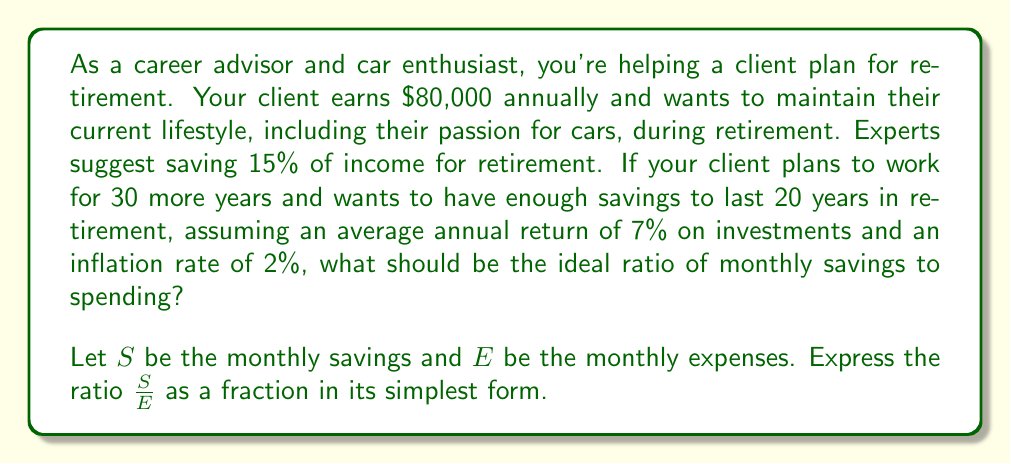Can you answer this question? To solve this problem, we'll follow these steps:

1) Calculate the monthly income:
   $\frac{\$80,000}{12} = \$6,666.67$ per month

2) Calculate the recommended monthly savings:
   $15\% \text{ of } \$6,666.67 = 0.15 \times \$6,666.67 = \$1,000$

3) Calculate the monthly expenses:
   $E = \$6,666.67 - \$1,000 = \$5,666.67$

4) Express the ratio of savings to expenses:
   $\frac{S}{E} = \frac{1000}{5666.67} = \frac{1000}{5666.67} \times \frac{3}{3} = \frac{3000}{17000}$

5) Simplify the fraction:
   $\frac{3000}{17000} = \frac{3}{17}$

This ratio suggests that for every $17 spent, $3 should be saved for retirement.

To verify if this savings rate is sufficient:

6) Calculate total savings over 30 years, assuming 7% annual return:
   $S = 1000 \times 12 \times \frac{(1.07^{30} - 1)}{0.07} \approx \$1,129,332$

7) Calculate required retirement income, adjusting for 2% inflation over 30 years:
   $80,000 \times 1.02^{30} \approx \$145,616$ annually

8) Check if savings are sufficient for 20 years of retirement:
   $\frac{1,129,332}{145,616} \approx 7.76$ years

The savings are not sufficient for 20 years, indicating that a higher savings rate might be necessary. However, the question asks for the ideal ratio based on the given 15% savings rate, so we'll stick with the calculated ratio.
Answer: The ideal ratio of monthly savings to spending is $\frac{3}{17}$. 